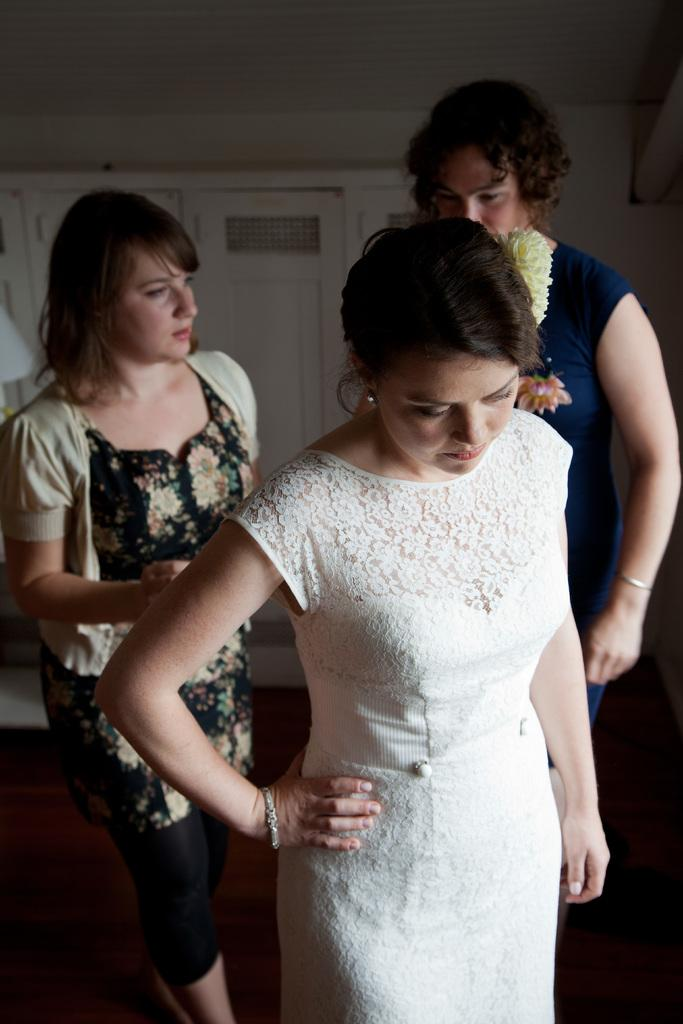What is the setting of the image? The image is of a room. How many people are in the room? There are three persons standing in the room. Is there any exit visible in the image? Yes, there is a door at the back of the room. What is the material of the floor in the room? The floor is made of wood. What type of basketball range can be seen in the image? There is no basketball range present in the image; it is a room with three persons standing in it. 